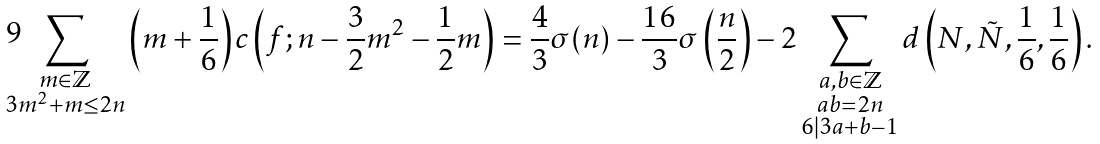Convert formula to latex. <formula><loc_0><loc_0><loc_500><loc_500>\sum _ { \substack { m \in \mathbb { Z } \\ 3 m ^ { 2 } + m \leq 2 n } } \left ( m + \frac { 1 } { 6 } \right ) c \left ( f ; n - \frac { 3 } { 2 } m ^ { 2 } - \frac { 1 } { 2 } m \right ) = \frac { 4 } { 3 } \sigma ( n ) - \frac { 1 6 } { 3 } \sigma \left ( \frac { n } { 2 } \right ) - 2 \sum _ { \substack { a , b \in \mathbb { Z } \\ a b = 2 n \\ 6 | 3 a + b - 1 } } d \left ( N , \tilde { N } , \frac { 1 } { 6 } , \frac { 1 } { 6 } \right ) .</formula> 